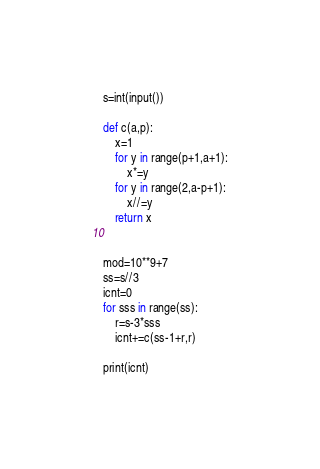<code> <loc_0><loc_0><loc_500><loc_500><_Python_>s=int(input())

def c(a,p):
    x=1
    for y in range(p+1,a+1):
        x*=y
    for y in range(2,a-p+1):
        x//=y
    return x
    

mod=10**9+7
ss=s//3
icnt=0
for sss in range(ss):
    r=s-3*sss
    icnt+=c(ss-1+r,r)

print(icnt)
</code> 